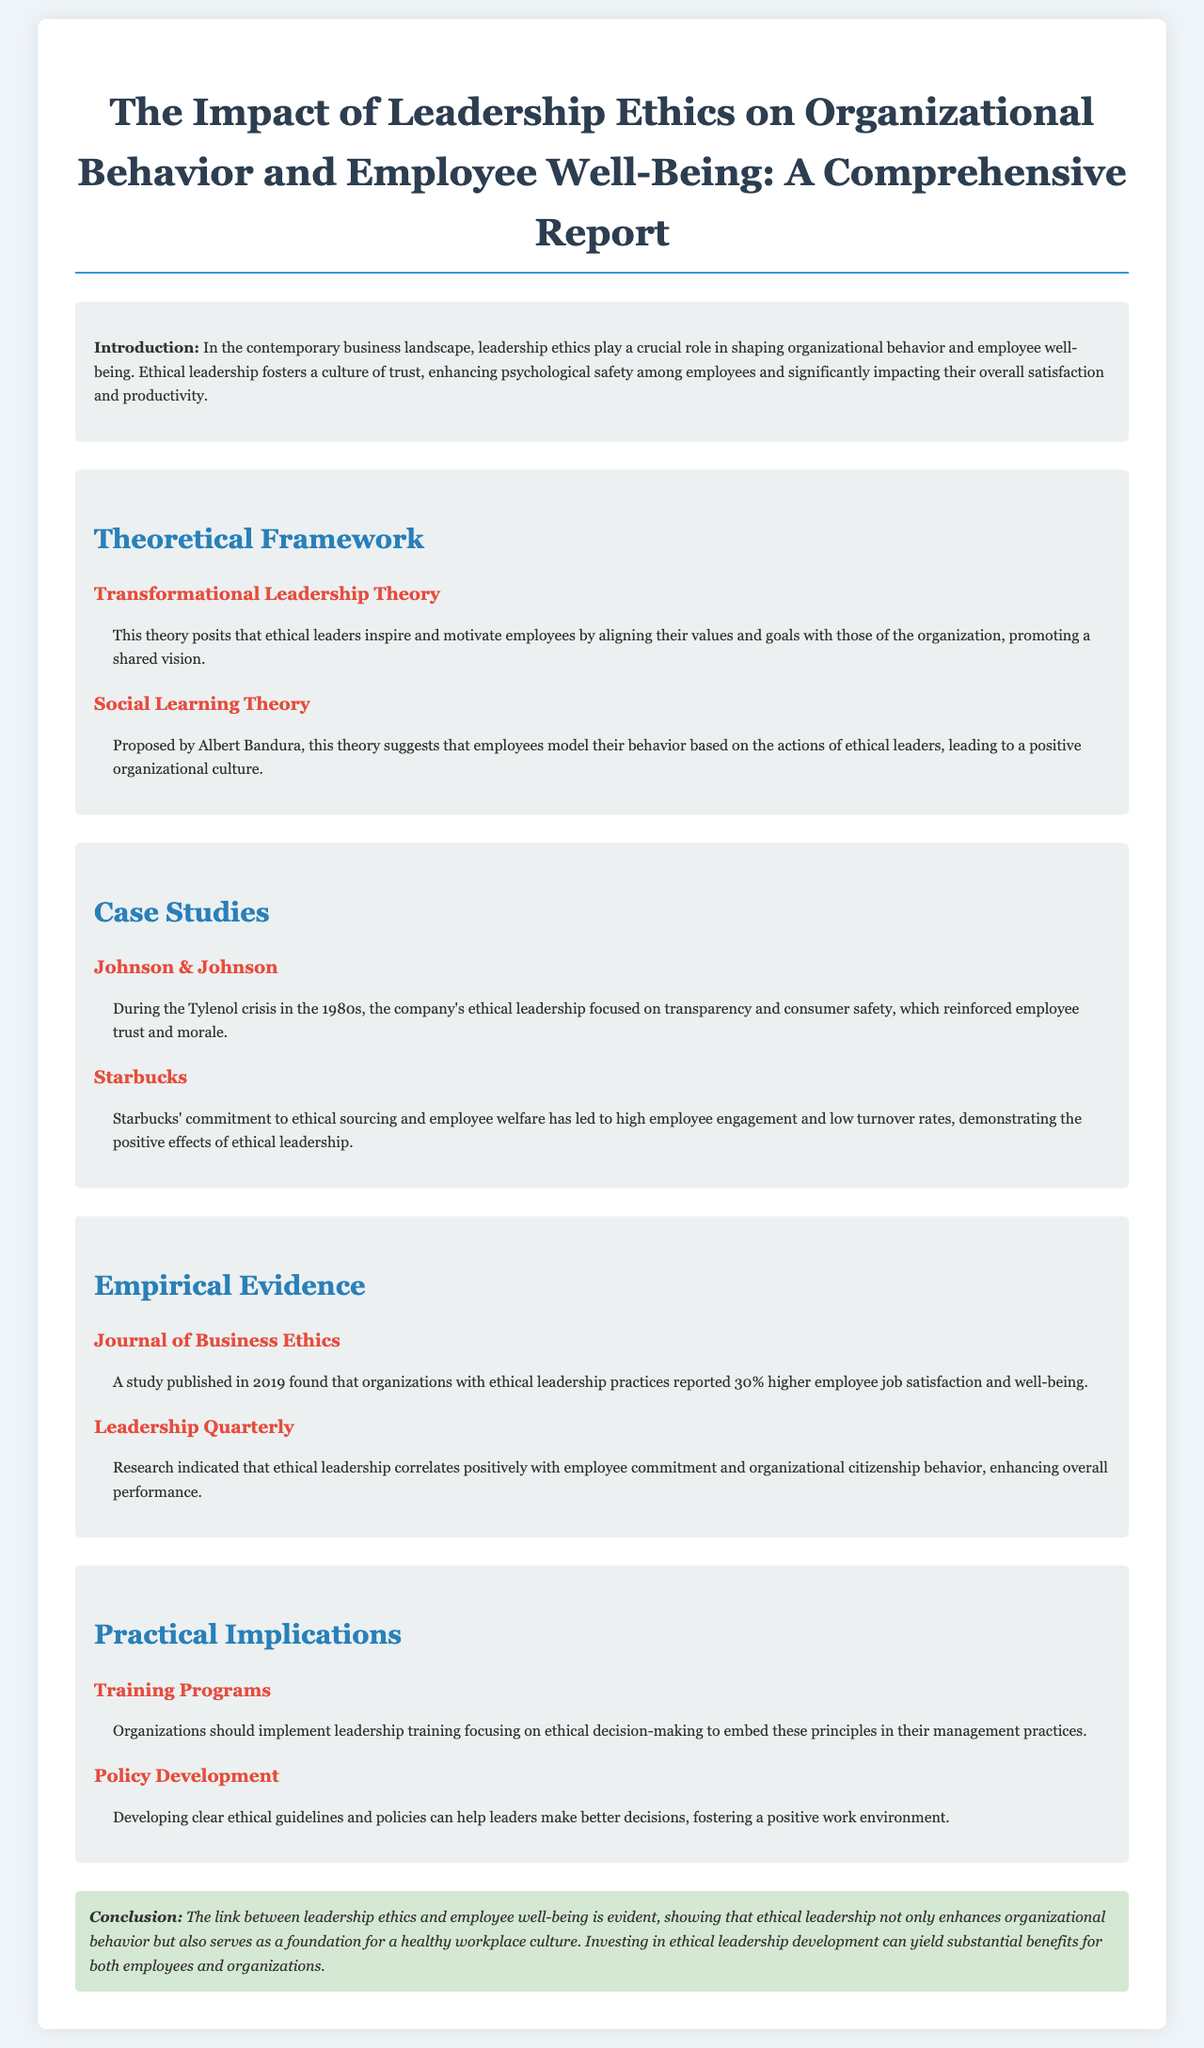What is the title of the report? The title of the report is presented at the top of the document.
Answer: The Impact of Leadership Ethics on Organizational Behavior and Employee Well-Being: A Comprehensive Report What theory suggests that ethical leaders inspire employees by aligning their values? This theory is outlined in the section discussing leadership theories in the document.
Answer: Transformational Leadership Theory Which company is mentioned in relation to the Tylenol crisis? The company is highlighted as a case study illustrating ethical leadership during a crisis.
Answer: Johnson & Johnson What percentage increase in job satisfaction was reported in the 2019 study? This information comes from the empirical evidence section that cites a study from a specific journal.
Answer: 30% What does the report suggest organizations implement to promote ethical decision-making? This recommendation is found in the practical implications section regarding leadership development.
Answer: Training Programs What ethical principle is emphasized as essential for enhancing organizational behavior? The conclusion highlights the importance of this principle in relation to workplace culture and well-being.
Answer: Ethical Leadership 